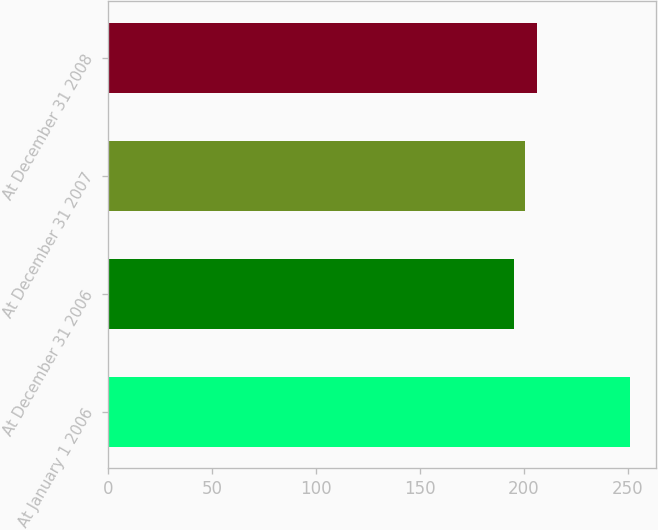Convert chart. <chart><loc_0><loc_0><loc_500><loc_500><bar_chart><fcel>At January 1 2006<fcel>At December 31 2006<fcel>At December 31 2007<fcel>At December 31 2008<nl><fcel>251<fcel>195<fcel>200.6<fcel>206.2<nl></chart> 